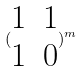<formula> <loc_0><loc_0><loc_500><loc_500>( \begin{matrix} 1 & 1 \\ 1 & 0 \end{matrix} ) ^ { m }</formula> 